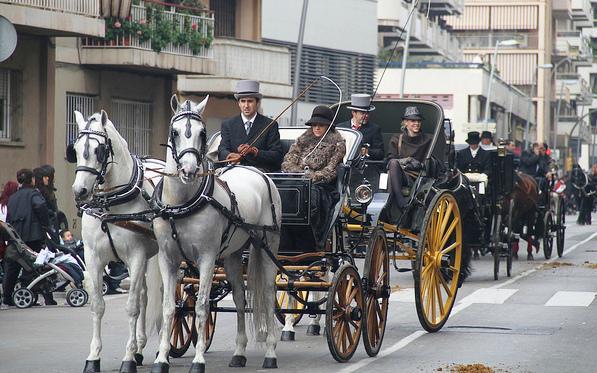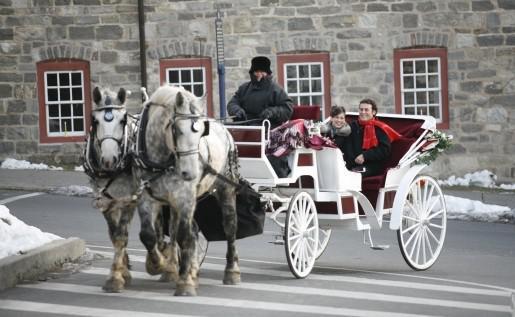The first image is the image on the left, the second image is the image on the right. Given the left and right images, does the statement "One image features a four-wheeled cart pulled by just one horse." hold true? Answer yes or no. No. The first image is the image on the left, the second image is the image on the right. For the images shown, is this caption "One of the images contains a white carriage." true? Answer yes or no. Yes. 